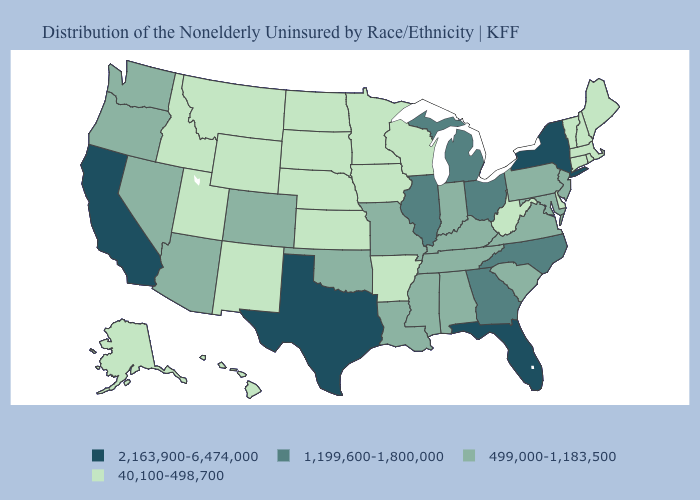What is the value of Florida?
Answer briefly. 2,163,900-6,474,000. What is the lowest value in the USA?
Short answer required. 40,100-498,700. What is the highest value in states that border Rhode Island?
Quick response, please. 40,100-498,700. What is the value of Minnesota?
Be succinct. 40,100-498,700. What is the value of Iowa?
Keep it brief. 40,100-498,700. What is the highest value in the MidWest ?
Keep it brief. 1,199,600-1,800,000. Does the first symbol in the legend represent the smallest category?
Answer briefly. No. What is the value of Massachusetts?
Be succinct. 40,100-498,700. Name the states that have a value in the range 1,199,600-1,800,000?
Quick response, please. Georgia, Illinois, Michigan, North Carolina, Ohio. Does West Virginia have the lowest value in the South?
Concise answer only. Yes. Among the states that border Utah , does Idaho have the lowest value?
Give a very brief answer. Yes. Which states have the lowest value in the Northeast?
Short answer required. Connecticut, Maine, Massachusetts, New Hampshire, Rhode Island, Vermont. What is the highest value in the MidWest ?
Be succinct. 1,199,600-1,800,000. What is the value of Massachusetts?
Answer briefly. 40,100-498,700. 